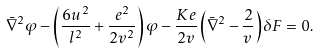<formula> <loc_0><loc_0><loc_500><loc_500>\bar { \nabla } ^ { 2 } \varphi - \left ( \frac { 6 u ^ { 2 } } { l ^ { 2 } } + \frac { e ^ { 2 } } { 2 v ^ { 2 } } \right ) \varphi - \frac { K e } { 2 v } \left ( \bar { \nabla } ^ { 2 } - \frac { 2 } { v } \right ) \delta F = 0 .</formula> 